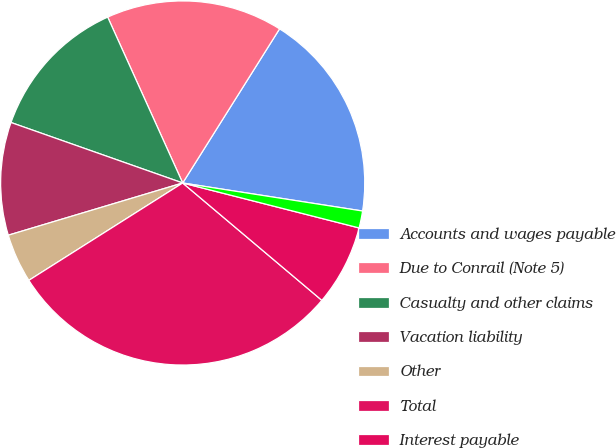Convert chart. <chart><loc_0><loc_0><loc_500><loc_500><pie_chart><fcel>Accounts and wages payable<fcel>Due to Conrail (Note 5)<fcel>Casualty and other claims<fcel>Vacation liability<fcel>Other<fcel>Total<fcel>Interest payable<fcel>Postretirement and pension<nl><fcel>18.53%<fcel>15.69%<fcel>12.85%<fcel>10.02%<fcel>4.35%<fcel>29.87%<fcel>7.18%<fcel>1.51%<nl></chart> 